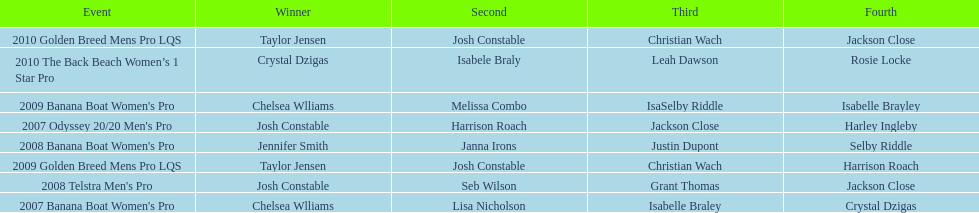How many times was josh constable second? 2. 